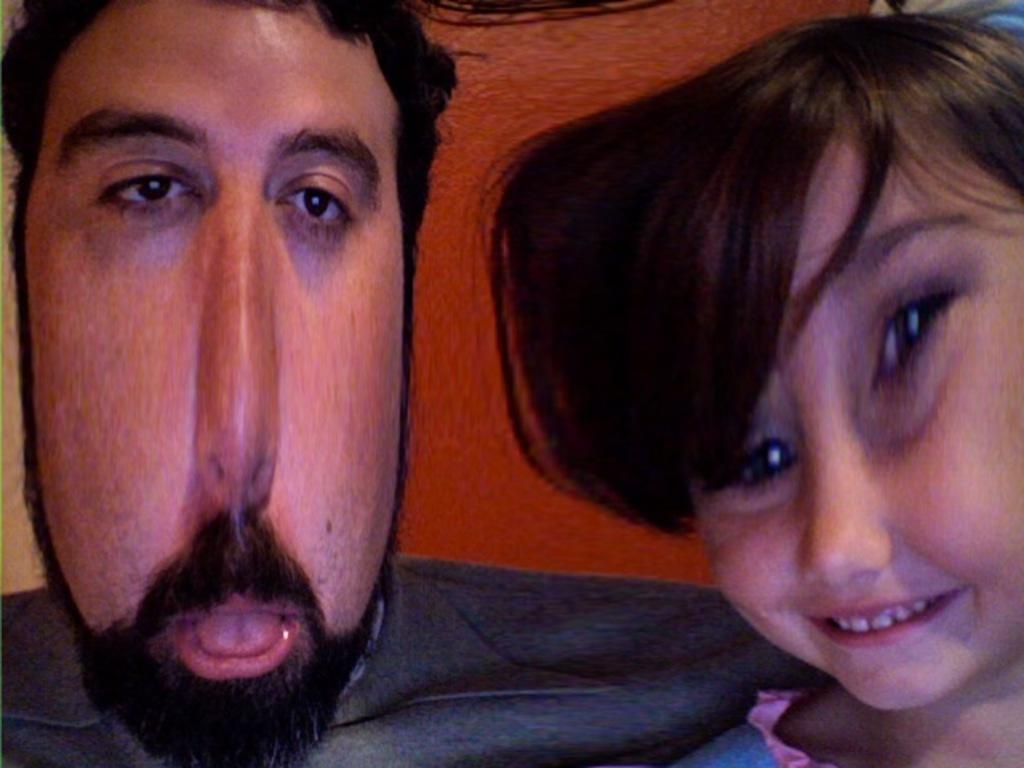Could you give a brief overview of what you see in this image? This is an edited image, in which, there is a person near a girl, who is smiling. In the background, there is an orange color wall. 